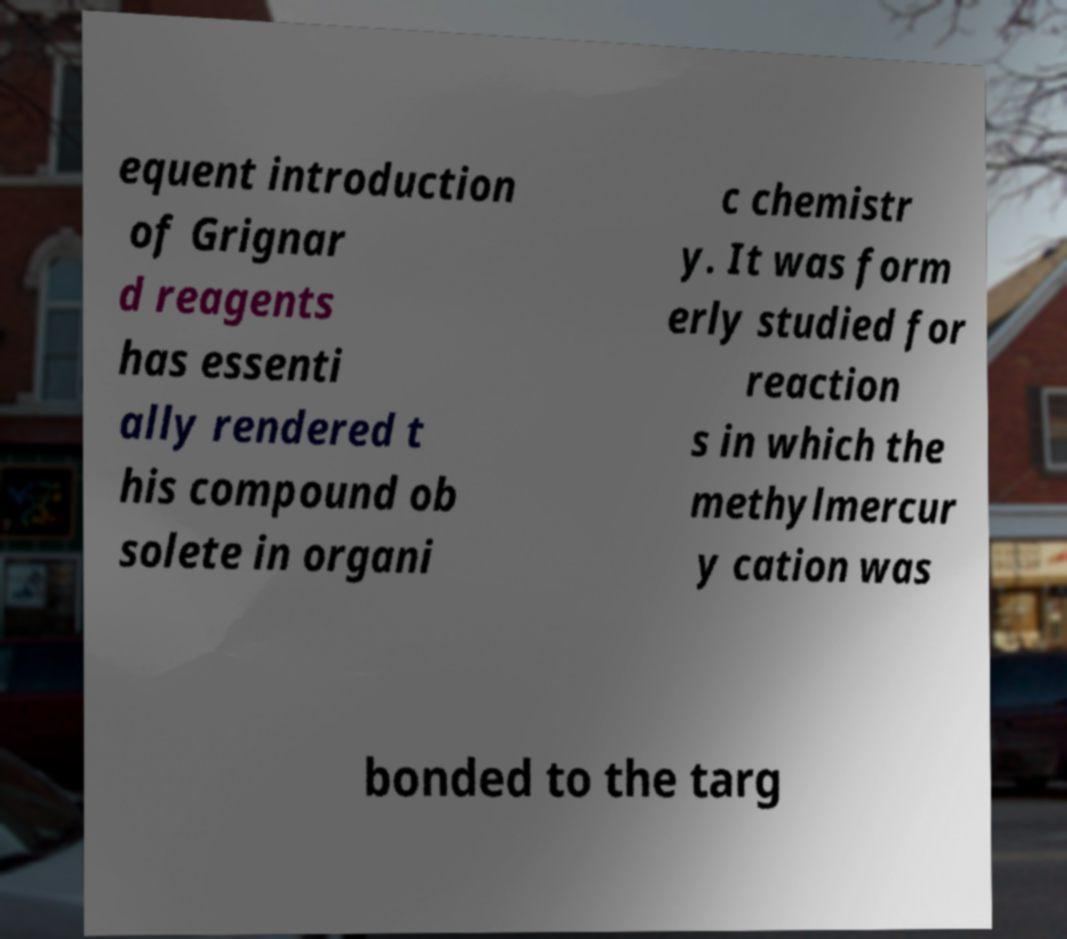Can you read and provide the text displayed in the image?This photo seems to have some interesting text. Can you extract and type it out for me? equent introduction of Grignar d reagents has essenti ally rendered t his compound ob solete in organi c chemistr y. It was form erly studied for reaction s in which the methylmercur y cation was bonded to the targ 